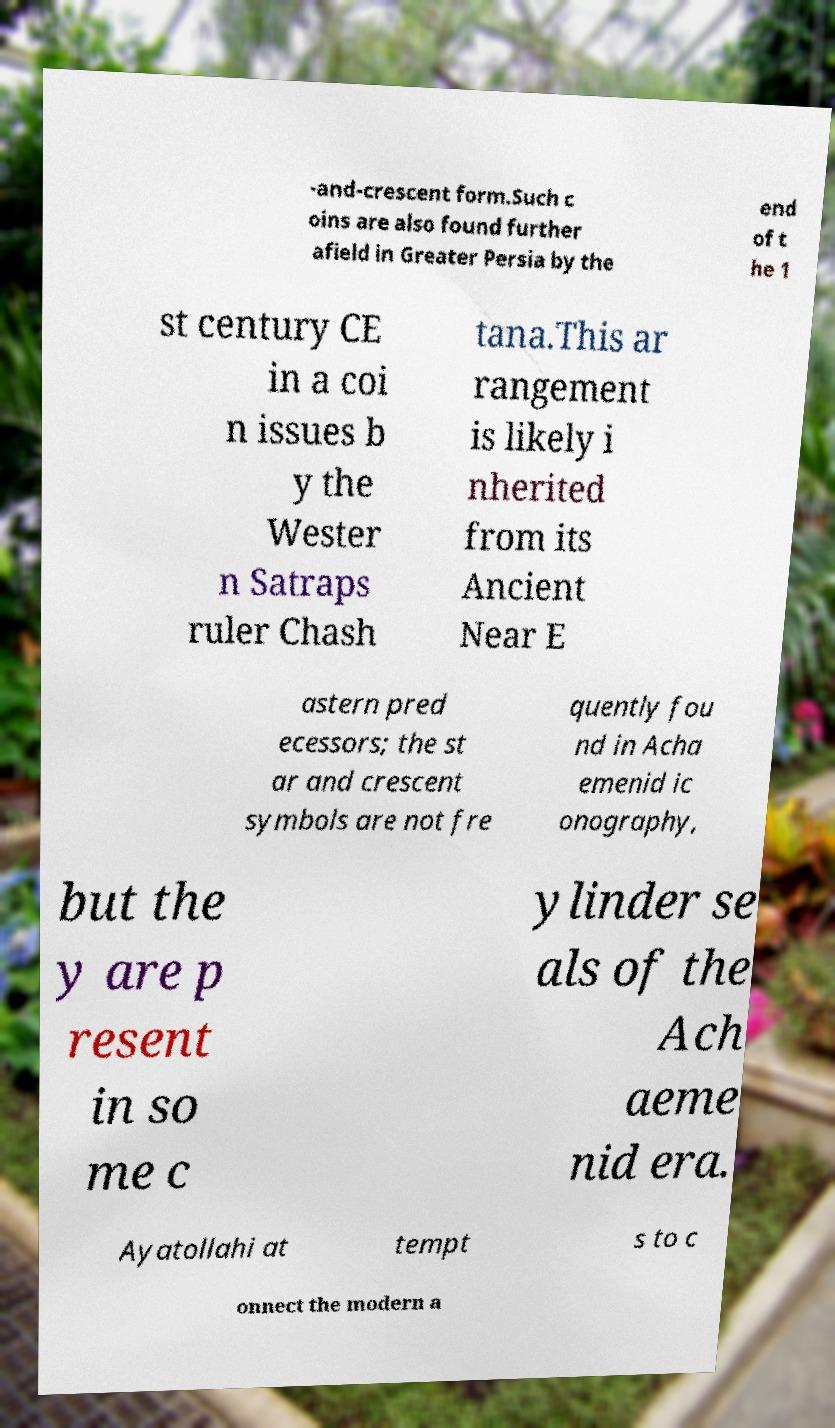Could you assist in decoding the text presented in this image and type it out clearly? -and-crescent form.Such c oins are also found further afield in Greater Persia by the end of t he 1 st century CE in a coi n issues b y the Wester n Satraps ruler Chash tana.This ar rangement is likely i nherited from its Ancient Near E astern pred ecessors; the st ar and crescent symbols are not fre quently fou nd in Acha emenid ic onography, but the y are p resent in so me c ylinder se als of the Ach aeme nid era. Ayatollahi at tempt s to c onnect the modern a 